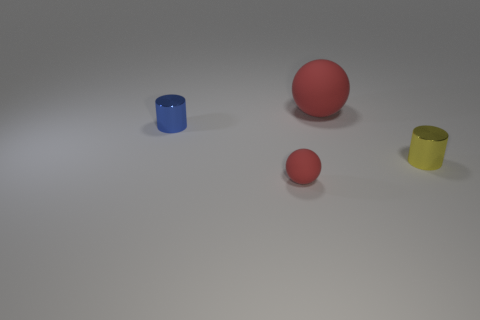Are there fewer large green cubes than big red things?
Offer a terse response. Yes. How many rubber things are large spheres or cylinders?
Give a very brief answer. 1. Is there a sphere that is on the right side of the metal thing that is in front of the blue shiny thing?
Make the answer very short. No. Is the red sphere behind the blue thing made of the same material as the yellow cylinder?
Offer a terse response. No. How many other objects are there of the same color as the small rubber thing?
Provide a succinct answer. 1. Is the small matte sphere the same color as the large matte ball?
Your answer should be compact. Yes. There is a rubber sphere that is in front of the metal cylinder that is on the right side of the small blue shiny object; what size is it?
Offer a very short reply. Small. Does the tiny cylinder that is on the left side of the small yellow shiny object have the same material as the tiny yellow cylinder to the right of the tiny blue metallic cylinder?
Provide a succinct answer. Yes. Does the rubber ball that is to the left of the large red thing have the same color as the large object?
Keep it short and to the point. Yes. What number of tiny cylinders are behind the small red rubber sphere?
Your response must be concise. 2. 